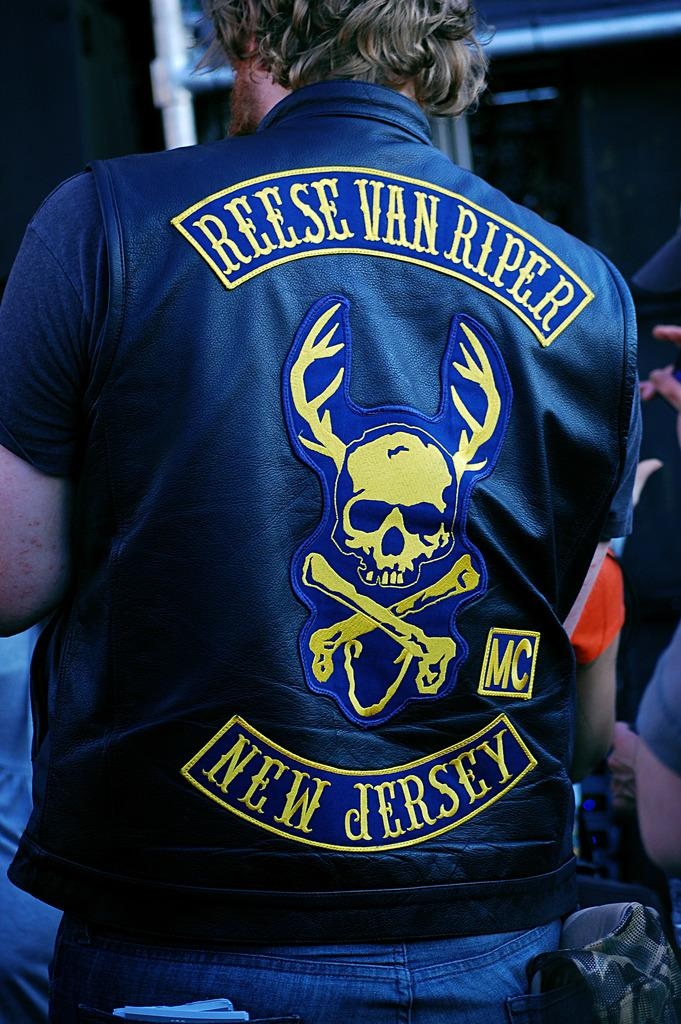<image>
Describe the image concisely. A man is wearing a leather vest, which reads "Reese Van Riper New Jersey" on the back. 